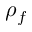<formula> <loc_0><loc_0><loc_500><loc_500>\rho _ { f }</formula> 